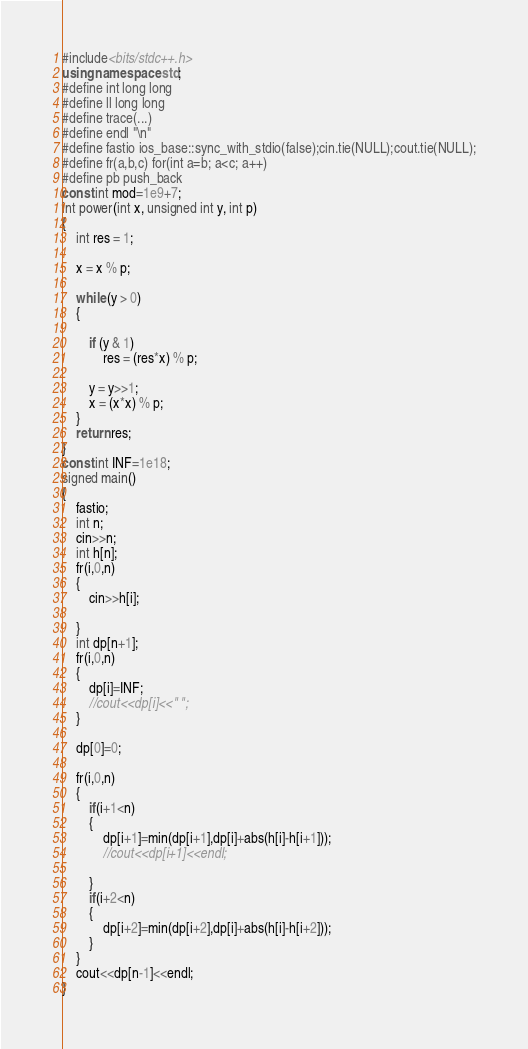<code> <loc_0><loc_0><loc_500><loc_500><_C++_>#include<bits/stdc++.h>
using namespace std;
#define int long long
#define ll long long
#define trace(...)
#define endl "\n"
#define fastio ios_base::sync_with_stdio(false);cin.tie(NULL);cout.tie(NULL);
#define fr(a,b,c) for(int a=b; a<c; a++)
#define pb push_back
const int mod=1e9+7;
int power(int x, unsigned int y, int p)
{
    int res = 1;

    x = x % p;

    while (y > 0)
    {

        if (y & 1)
            res = (res*x) % p;

        y = y>>1;
        x = (x*x) % p;
    }
    return res;
}
const int INF=1e18;
signed main()
{
    fastio;
    int n;
    cin>>n;
    int h[n];
    fr(i,0,n)
    {
        cin>>h[i];

    }
    int dp[n+1];
    fr(i,0,n)
    {
        dp[i]=INF;
        //cout<<dp[i]<<" ";
    }

    dp[0]=0;

    fr(i,0,n)
    {
        if(i+1<n)
        {
            dp[i+1]=min(dp[i+1],dp[i]+abs(h[i]-h[i+1]));
            //cout<<dp[i+1]<<endl;

        }
        if(i+2<n)
        {
            dp[i+2]=min(dp[i+2],dp[i]+abs(h[i]-h[i+2]));
        }
    }
    cout<<dp[n-1]<<endl;
}
</code> 